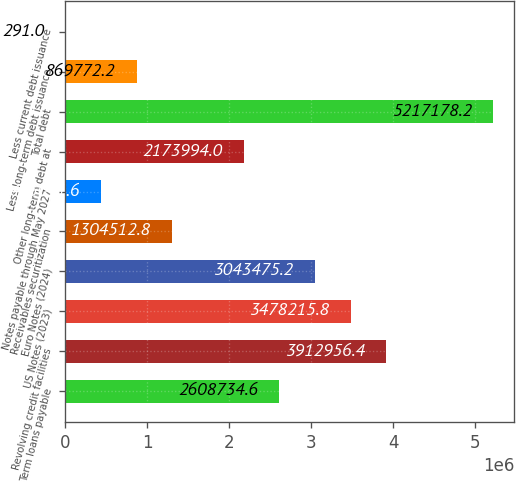Convert chart. <chart><loc_0><loc_0><loc_500><loc_500><bar_chart><fcel>Term loans payable<fcel>Revolving credit facilities<fcel>US Notes (2023)<fcel>Euro Notes (2024)<fcel>Receivables securitization<fcel>Notes payable through May 2027<fcel>Other long-term debt at<fcel>Total debt<fcel>Less long-term debt issuance<fcel>Less current debt issuance<nl><fcel>2.60873e+06<fcel>3.91296e+06<fcel>3.47822e+06<fcel>3.04348e+06<fcel>1.30451e+06<fcel>435032<fcel>2.17399e+06<fcel>5.21718e+06<fcel>869772<fcel>291<nl></chart> 